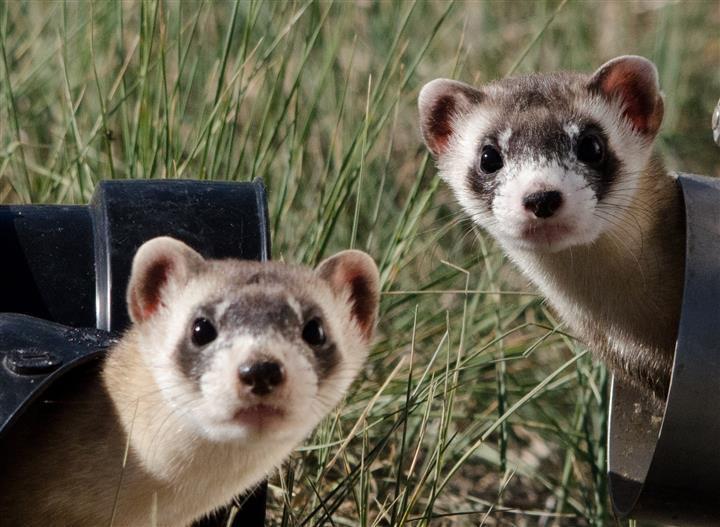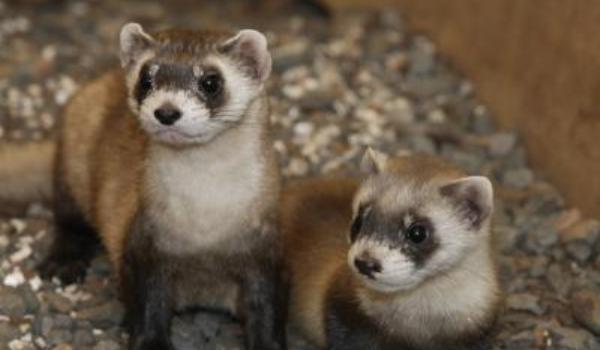The first image is the image on the left, the second image is the image on the right. Considering the images on both sides, is "Three prairie dogs are poking their heads out of the ground in one of the images." valid? Answer yes or no. No. 